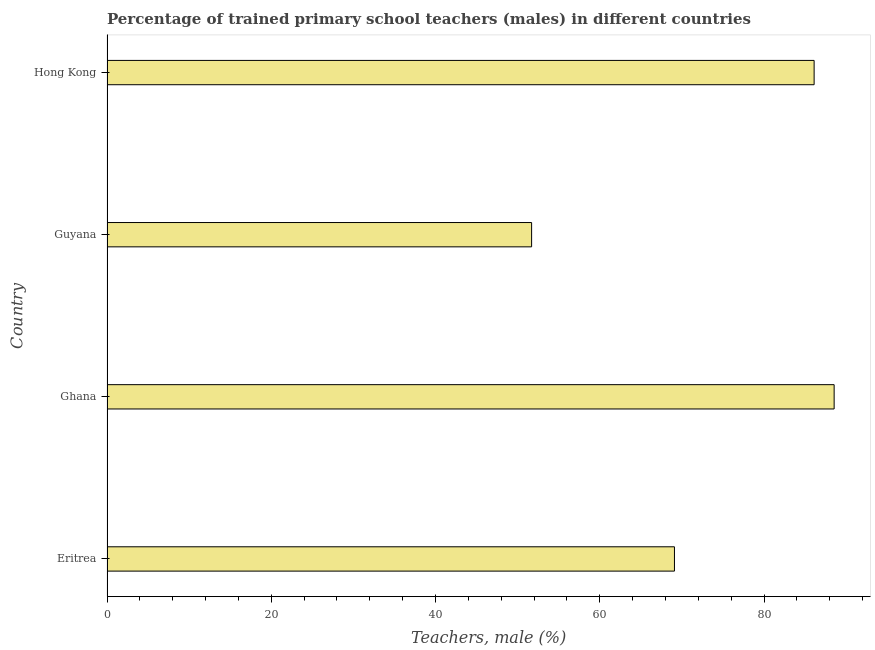What is the title of the graph?
Keep it short and to the point. Percentage of trained primary school teachers (males) in different countries. What is the label or title of the X-axis?
Make the answer very short. Teachers, male (%). What is the label or title of the Y-axis?
Provide a short and direct response. Country. What is the percentage of trained male teachers in Eritrea?
Make the answer very short. 69.09. Across all countries, what is the maximum percentage of trained male teachers?
Provide a succinct answer. 88.54. Across all countries, what is the minimum percentage of trained male teachers?
Offer a very short reply. 51.7. In which country was the percentage of trained male teachers minimum?
Give a very brief answer. Guyana. What is the sum of the percentage of trained male teachers?
Your answer should be very brief. 295.43. What is the difference between the percentage of trained male teachers in Eritrea and Ghana?
Make the answer very short. -19.44. What is the average percentage of trained male teachers per country?
Offer a very short reply. 73.86. What is the median percentage of trained male teachers?
Your response must be concise. 77.6. In how many countries, is the percentage of trained male teachers greater than 16 %?
Make the answer very short. 4. What is the ratio of the percentage of trained male teachers in Eritrea to that in Hong Kong?
Provide a succinct answer. 0.8. What is the difference between the highest and the second highest percentage of trained male teachers?
Offer a terse response. 2.44. What is the difference between the highest and the lowest percentage of trained male teachers?
Offer a very short reply. 36.84. Are all the bars in the graph horizontal?
Offer a terse response. Yes. How many countries are there in the graph?
Your answer should be compact. 4. Are the values on the major ticks of X-axis written in scientific E-notation?
Your response must be concise. No. What is the Teachers, male (%) in Eritrea?
Make the answer very short. 69.09. What is the Teachers, male (%) in Ghana?
Your response must be concise. 88.54. What is the Teachers, male (%) in Guyana?
Your response must be concise. 51.7. What is the Teachers, male (%) in Hong Kong?
Keep it short and to the point. 86.1. What is the difference between the Teachers, male (%) in Eritrea and Ghana?
Your answer should be very brief. -19.44. What is the difference between the Teachers, male (%) in Eritrea and Guyana?
Your answer should be very brief. 17.39. What is the difference between the Teachers, male (%) in Eritrea and Hong Kong?
Your response must be concise. -17.01. What is the difference between the Teachers, male (%) in Ghana and Guyana?
Provide a succinct answer. 36.84. What is the difference between the Teachers, male (%) in Ghana and Hong Kong?
Keep it short and to the point. 2.44. What is the difference between the Teachers, male (%) in Guyana and Hong Kong?
Give a very brief answer. -34.4. What is the ratio of the Teachers, male (%) in Eritrea to that in Ghana?
Give a very brief answer. 0.78. What is the ratio of the Teachers, male (%) in Eritrea to that in Guyana?
Offer a terse response. 1.34. What is the ratio of the Teachers, male (%) in Eritrea to that in Hong Kong?
Your response must be concise. 0.8. What is the ratio of the Teachers, male (%) in Ghana to that in Guyana?
Make the answer very short. 1.71. What is the ratio of the Teachers, male (%) in Ghana to that in Hong Kong?
Offer a very short reply. 1.03. What is the ratio of the Teachers, male (%) in Guyana to that in Hong Kong?
Ensure brevity in your answer.  0.6. 